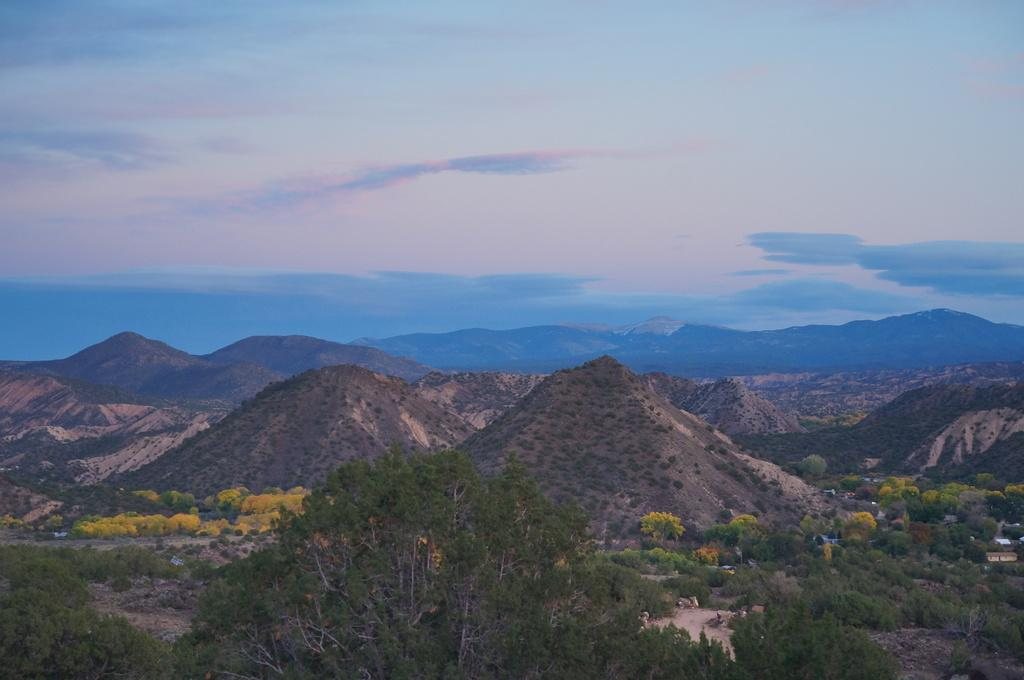What type of landscape is depicted in the image? The image features hills and trees. Can you describe the sky in the image? The sky is cloudy and pale blue with pale purple hues. What type of pain is the woman experiencing while holding the silver object in the image? There is no woman or silver object present in the image; it only features hills, trees, and a cloudy sky. 